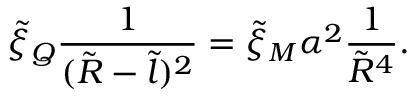Convert formula to latex. <formula><loc_0><loc_0><loc_500><loc_500>\tilde { \xi } _ { Q } \frac { 1 } { ( \tilde { R } - \tilde { l } ) ^ { 2 } } = \tilde { \xi } _ { M } \alpha ^ { 2 } \frac { 1 } { \tilde { R } ^ { 4 } } .</formula> 